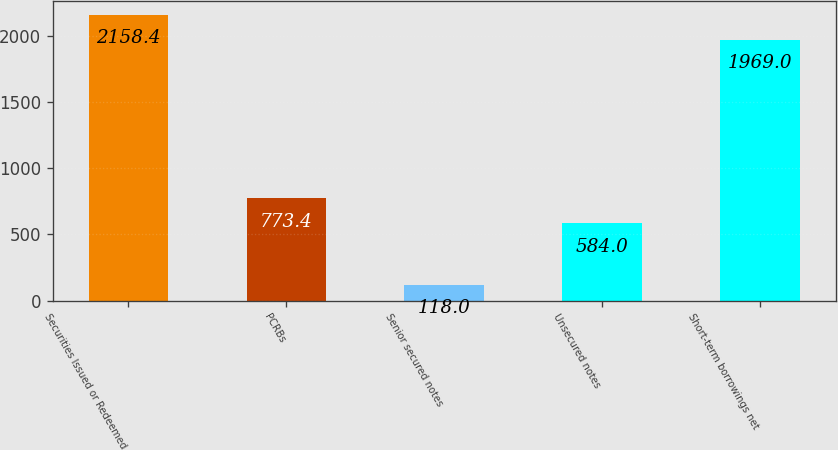Convert chart. <chart><loc_0><loc_0><loc_500><loc_500><bar_chart><fcel>Securities Issued or Redeemed<fcel>PCRBs<fcel>Senior secured notes<fcel>Unsecured notes<fcel>Short-term borrowings net<nl><fcel>2158.4<fcel>773.4<fcel>118<fcel>584<fcel>1969<nl></chart> 